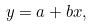Convert formula to latex. <formula><loc_0><loc_0><loc_500><loc_500>y = a + b x ,</formula> 